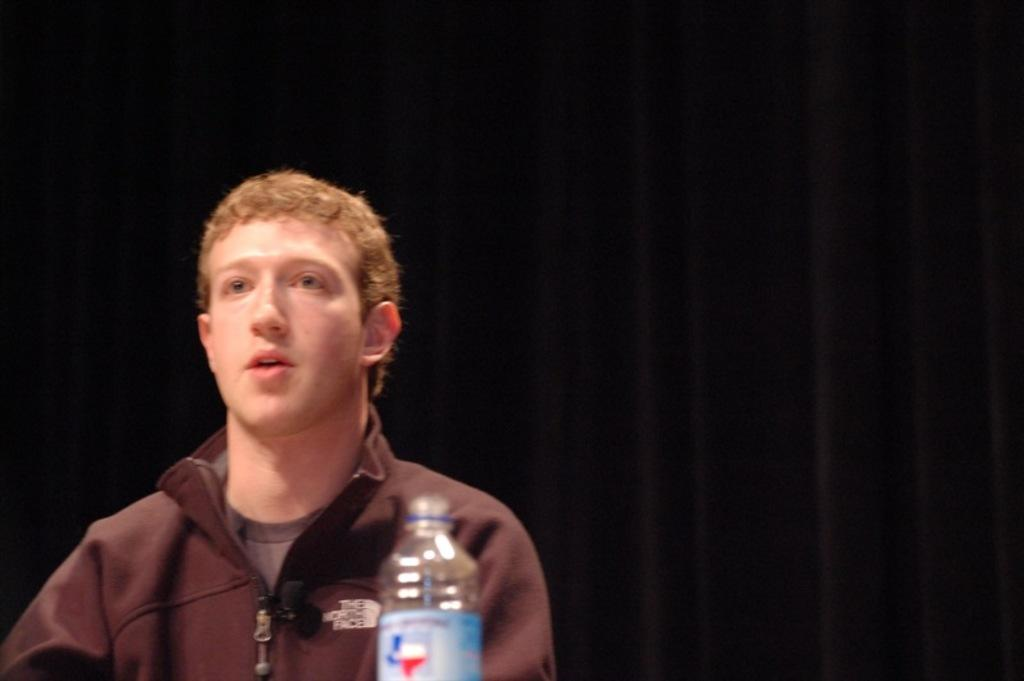What is the main subject of the image? There is a man in the image. What object is in front of the man? There is a bottle in front of the man. How many frogs are sitting on the truck in the image? There are no frogs or trucks present in the image. What is the man doing with the earth in the image? There is no mention of the man interacting with the earth in the image. 